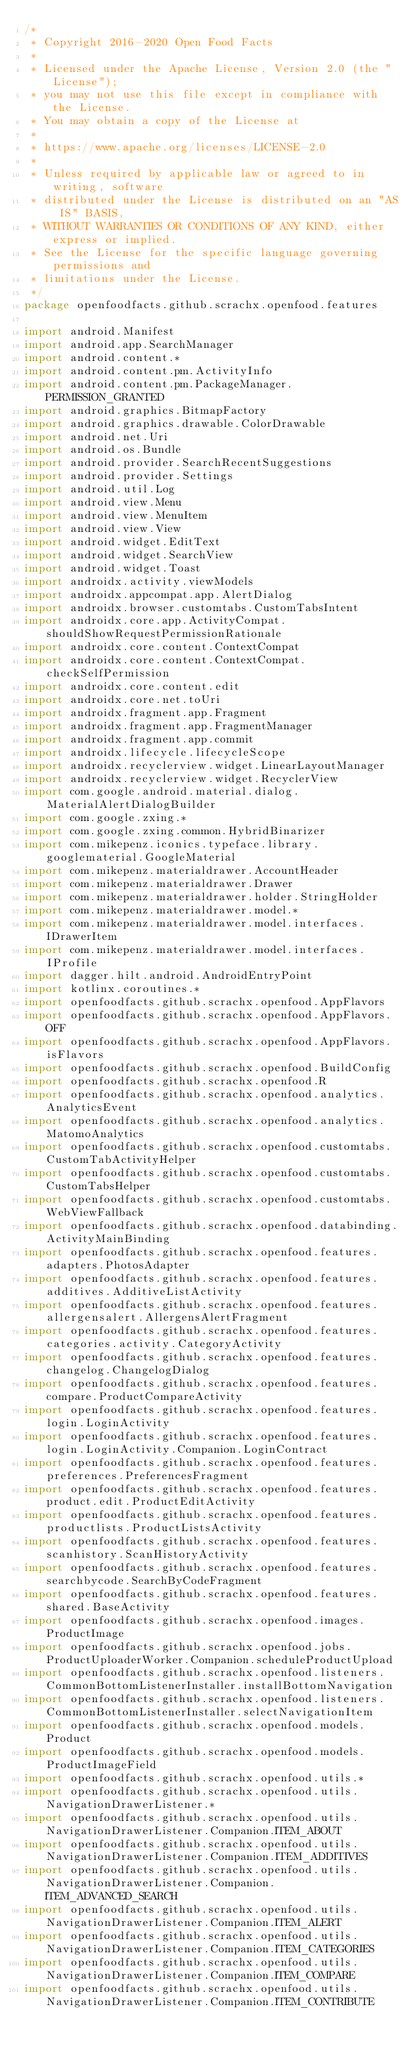<code> <loc_0><loc_0><loc_500><loc_500><_Kotlin_>/*
 * Copyright 2016-2020 Open Food Facts
 *
 * Licensed under the Apache License, Version 2.0 (the "License");
 * you may not use this file except in compliance with the License.
 * You may obtain a copy of the License at
 *
 * https://www.apache.org/licenses/LICENSE-2.0
 *
 * Unless required by applicable law or agreed to in writing, software
 * distributed under the License is distributed on an "AS IS" BASIS,
 * WITHOUT WARRANTIES OR CONDITIONS OF ANY KIND, either express or implied.
 * See the License for the specific language governing permissions and
 * limitations under the License.
 */
package openfoodfacts.github.scrachx.openfood.features

import android.Manifest
import android.app.SearchManager
import android.content.*
import android.content.pm.ActivityInfo
import android.content.pm.PackageManager.PERMISSION_GRANTED
import android.graphics.BitmapFactory
import android.graphics.drawable.ColorDrawable
import android.net.Uri
import android.os.Bundle
import android.provider.SearchRecentSuggestions
import android.provider.Settings
import android.util.Log
import android.view.Menu
import android.view.MenuItem
import android.view.View
import android.widget.EditText
import android.widget.SearchView
import android.widget.Toast
import androidx.activity.viewModels
import androidx.appcompat.app.AlertDialog
import androidx.browser.customtabs.CustomTabsIntent
import androidx.core.app.ActivityCompat.shouldShowRequestPermissionRationale
import androidx.core.content.ContextCompat
import androidx.core.content.ContextCompat.checkSelfPermission
import androidx.core.content.edit
import androidx.core.net.toUri
import androidx.fragment.app.Fragment
import androidx.fragment.app.FragmentManager
import androidx.fragment.app.commit
import androidx.lifecycle.lifecycleScope
import androidx.recyclerview.widget.LinearLayoutManager
import androidx.recyclerview.widget.RecyclerView
import com.google.android.material.dialog.MaterialAlertDialogBuilder
import com.google.zxing.*
import com.google.zxing.common.HybridBinarizer
import com.mikepenz.iconics.typeface.library.googlematerial.GoogleMaterial
import com.mikepenz.materialdrawer.AccountHeader
import com.mikepenz.materialdrawer.Drawer
import com.mikepenz.materialdrawer.holder.StringHolder
import com.mikepenz.materialdrawer.model.*
import com.mikepenz.materialdrawer.model.interfaces.IDrawerItem
import com.mikepenz.materialdrawer.model.interfaces.IProfile
import dagger.hilt.android.AndroidEntryPoint
import kotlinx.coroutines.*
import openfoodfacts.github.scrachx.openfood.AppFlavors
import openfoodfacts.github.scrachx.openfood.AppFlavors.OFF
import openfoodfacts.github.scrachx.openfood.AppFlavors.isFlavors
import openfoodfacts.github.scrachx.openfood.BuildConfig
import openfoodfacts.github.scrachx.openfood.R
import openfoodfacts.github.scrachx.openfood.analytics.AnalyticsEvent
import openfoodfacts.github.scrachx.openfood.analytics.MatomoAnalytics
import openfoodfacts.github.scrachx.openfood.customtabs.CustomTabActivityHelper
import openfoodfacts.github.scrachx.openfood.customtabs.CustomTabsHelper
import openfoodfacts.github.scrachx.openfood.customtabs.WebViewFallback
import openfoodfacts.github.scrachx.openfood.databinding.ActivityMainBinding
import openfoodfacts.github.scrachx.openfood.features.adapters.PhotosAdapter
import openfoodfacts.github.scrachx.openfood.features.additives.AdditiveListActivity
import openfoodfacts.github.scrachx.openfood.features.allergensalert.AllergensAlertFragment
import openfoodfacts.github.scrachx.openfood.features.categories.activity.CategoryActivity
import openfoodfacts.github.scrachx.openfood.features.changelog.ChangelogDialog
import openfoodfacts.github.scrachx.openfood.features.compare.ProductCompareActivity
import openfoodfacts.github.scrachx.openfood.features.login.LoginActivity
import openfoodfacts.github.scrachx.openfood.features.login.LoginActivity.Companion.LoginContract
import openfoodfacts.github.scrachx.openfood.features.preferences.PreferencesFragment
import openfoodfacts.github.scrachx.openfood.features.product.edit.ProductEditActivity
import openfoodfacts.github.scrachx.openfood.features.productlists.ProductListsActivity
import openfoodfacts.github.scrachx.openfood.features.scanhistory.ScanHistoryActivity
import openfoodfacts.github.scrachx.openfood.features.searchbycode.SearchByCodeFragment
import openfoodfacts.github.scrachx.openfood.features.shared.BaseActivity
import openfoodfacts.github.scrachx.openfood.images.ProductImage
import openfoodfacts.github.scrachx.openfood.jobs.ProductUploaderWorker.Companion.scheduleProductUpload
import openfoodfacts.github.scrachx.openfood.listeners.CommonBottomListenerInstaller.installBottomNavigation
import openfoodfacts.github.scrachx.openfood.listeners.CommonBottomListenerInstaller.selectNavigationItem
import openfoodfacts.github.scrachx.openfood.models.Product
import openfoodfacts.github.scrachx.openfood.models.ProductImageField
import openfoodfacts.github.scrachx.openfood.utils.*
import openfoodfacts.github.scrachx.openfood.utils.NavigationDrawerListener.*
import openfoodfacts.github.scrachx.openfood.utils.NavigationDrawerListener.Companion.ITEM_ABOUT
import openfoodfacts.github.scrachx.openfood.utils.NavigationDrawerListener.Companion.ITEM_ADDITIVES
import openfoodfacts.github.scrachx.openfood.utils.NavigationDrawerListener.Companion.ITEM_ADVANCED_SEARCH
import openfoodfacts.github.scrachx.openfood.utils.NavigationDrawerListener.Companion.ITEM_ALERT
import openfoodfacts.github.scrachx.openfood.utils.NavigationDrawerListener.Companion.ITEM_CATEGORIES
import openfoodfacts.github.scrachx.openfood.utils.NavigationDrawerListener.Companion.ITEM_COMPARE
import openfoodfacts.github.scrachx.openfood.utils.NavigationDrawerListener.Companion.ITEM_CONTRIBUTE</code> 